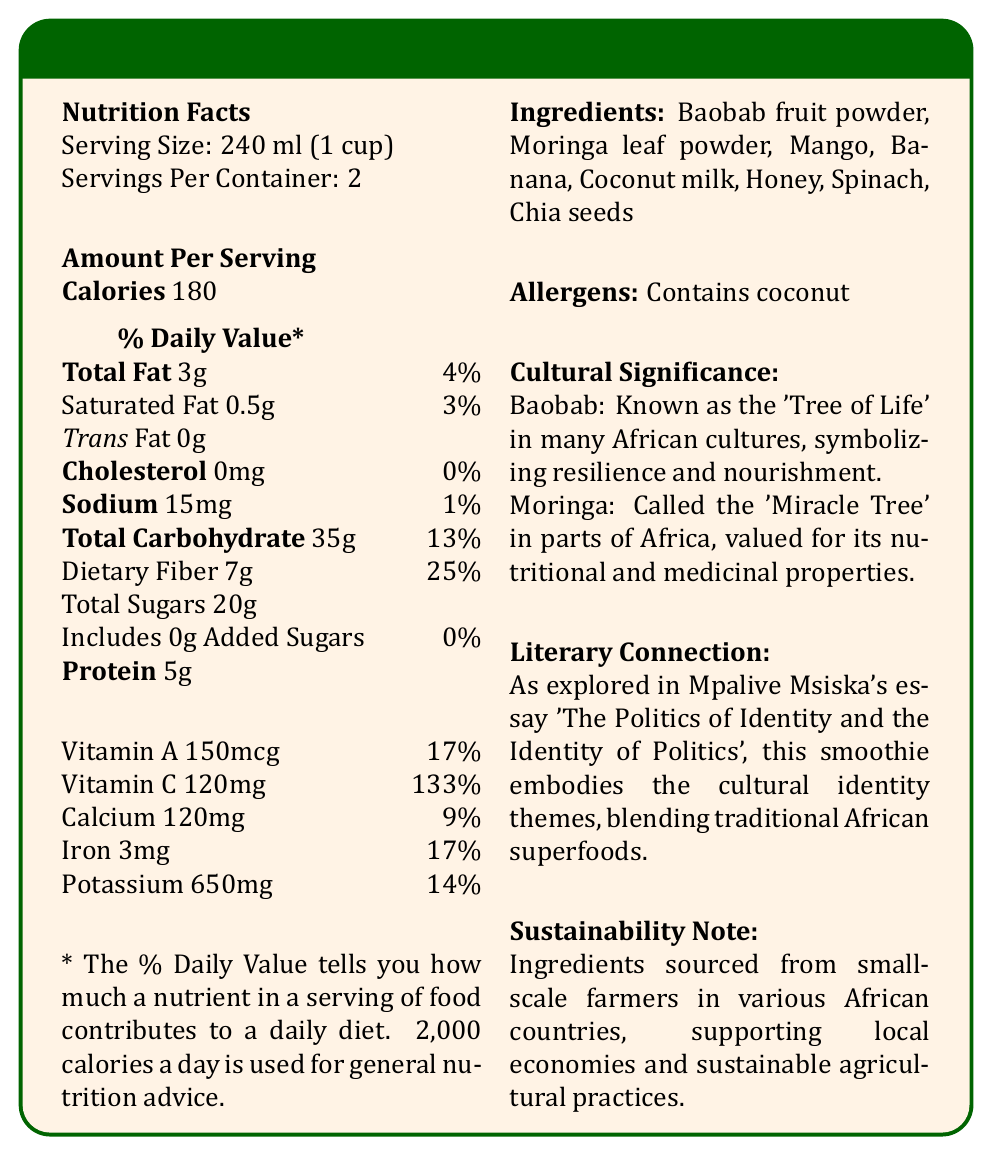what is the serving size of the African Superfood Smoothie? The serving size is explicitly mentioned as 240 ml (1 cup) in the Nutrition Facts section.
Answer: 240 ml (1 cup) how many calories are there per serving? The document states the calorie count per serving as 180.
Answer: 180 what is the total amount of fat per serving? The total fat per serving is listed as 3g in the Nutrition Facts section.
Answer: 3g what is the amount of dietary fiber in one serving? The document specifies the dietary fiber content as 7g per serving.
Answer: 7g which vitamin has the highest daily value percentage per serving? Vitamin C has a daily value percentage of 133%, which is the highest among the listed vitamins and minerals.
Answer: Vitamin C which superfood ingredients are mentioned in the smoothie? A. Baobab only B. Moringa only C. Both Baobab and Moringa D. Neither Baobab nor Moringa The ingredients list includes both Baobab fruit powder and Moringa leaf powder.
Answer: C how much protein is there in one serving of the smoothie? 1. 3g 2. 5g 3. 7g 4. 10g The protein content per serving is mentioned as 5g.
Answer: 2 does the African Superfood Smoothie contain any cholesterol? The document states that the cholesterol content is 0mg.
Answer: No are there any allergens in the smoothie? The smoothie contains coconut, which is listed under allergens.
Answer: Yes explain the cultural significance of the baobab and moringa ingredients? The document mentions the baobab's cultural symbolism as the 'Tree of Life' and moringa's reputation as the 'Miracle Tree' in African cultures.
Answer: Baobab is known as the 'Tree of Life' symbolizing resilience and nourishment, and Moringa is called the 'Miracle Tree' valued for nutritional and medicinal properties. summarize the main components and insights of the African Superfood Smoothie document The document includes detailed nutritional information, ingredient list, allergens, cultural and literary significance, and sustainability practices regarding the African Superfood Smoothie.
Answer: The African Superfood Smoothie document provides a nutritional breakdown of the smoothie, highlights the serving size, ingredients, and nutritional content per serving, and discusses cultural significance, literary connection, and sustainability notes. what is the total carbohydrate content in two servings of the smoothie? The document provides the carbohydrate content per serving but does not directly state the total for two servings.
Answer: Cannot be determined 